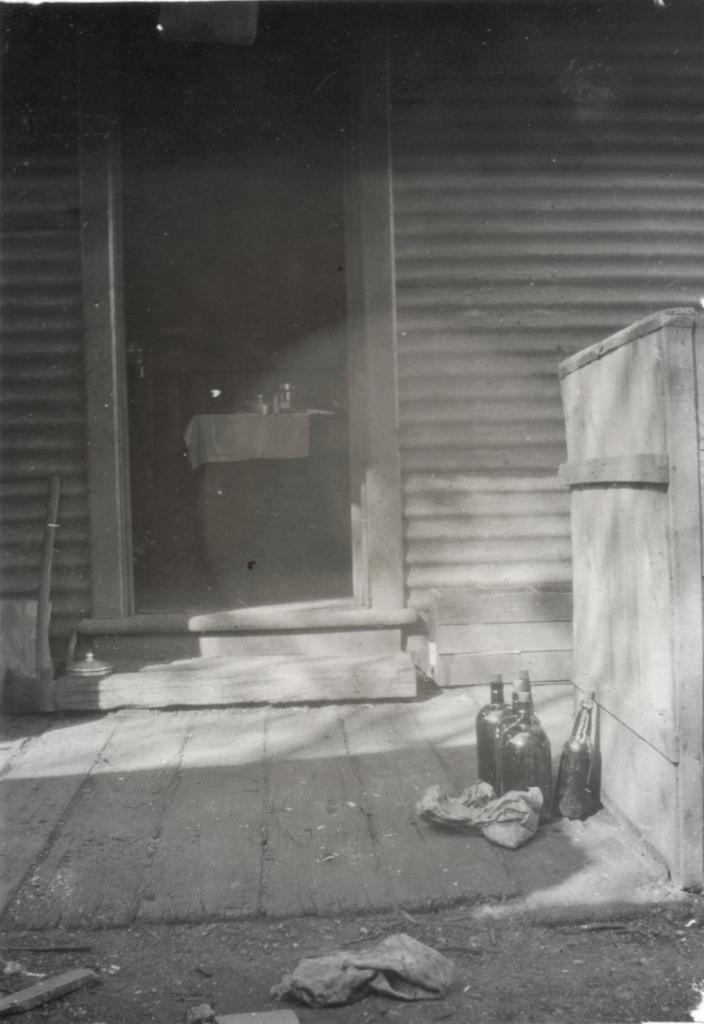In one or two sentences, can you explain what this image depicts? It is the black and white image in which we can see there is a door in the middle. Through the door we can see that there is a table on which there are jars. On the right side there is a wooden box. At the bottom there are glass bottles,cloth and papers on the floor. 